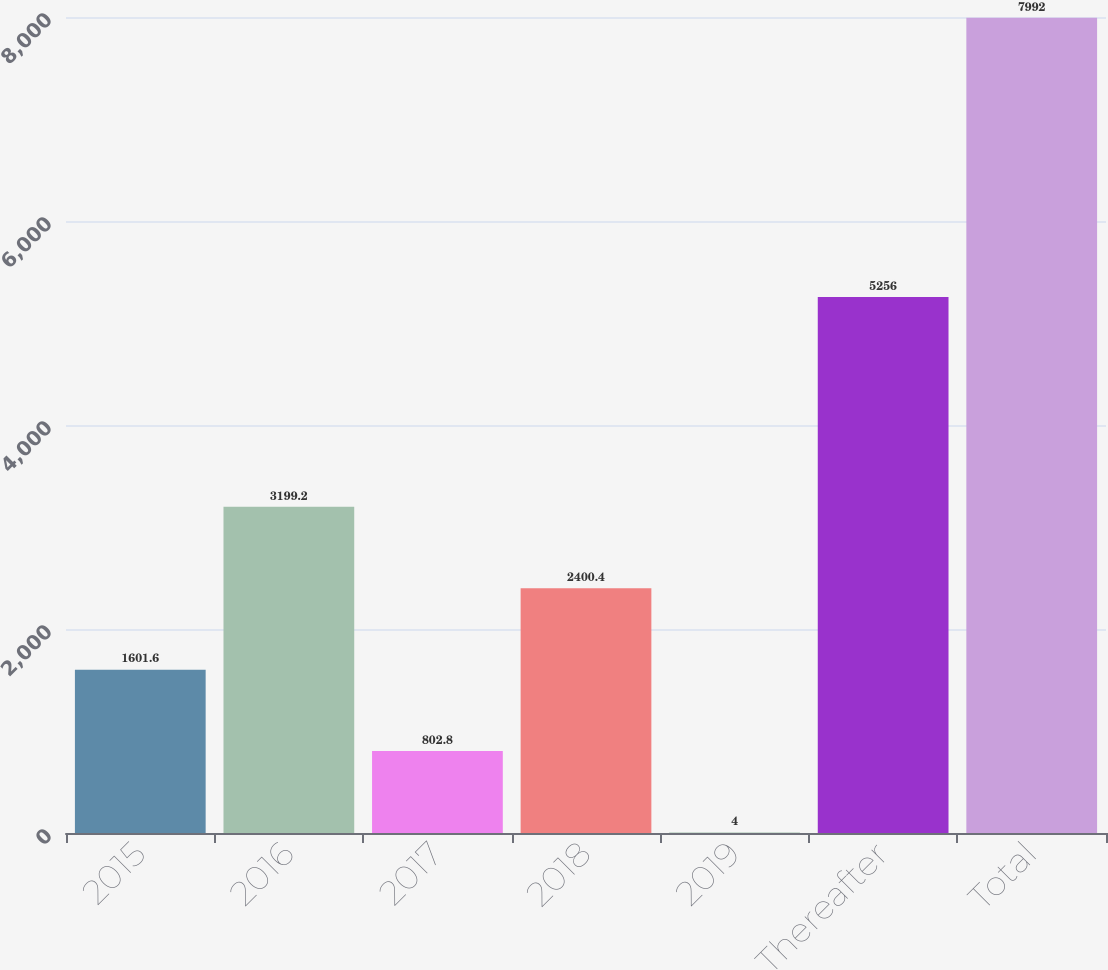<chart> <loc_0><loc_0><loc_500><loc_500><bar_chart><fcel>2015<fcel>2016<fcel>2017<fcel>2018<fcel>2019<fcel>Thereafter<fcel>Total<nl><fcel>1601.6<fcel>3199.2<fcel>802.8<fcel>2400.4<fcel>4<fcel>5256<fcel>7992<nl></chart> 